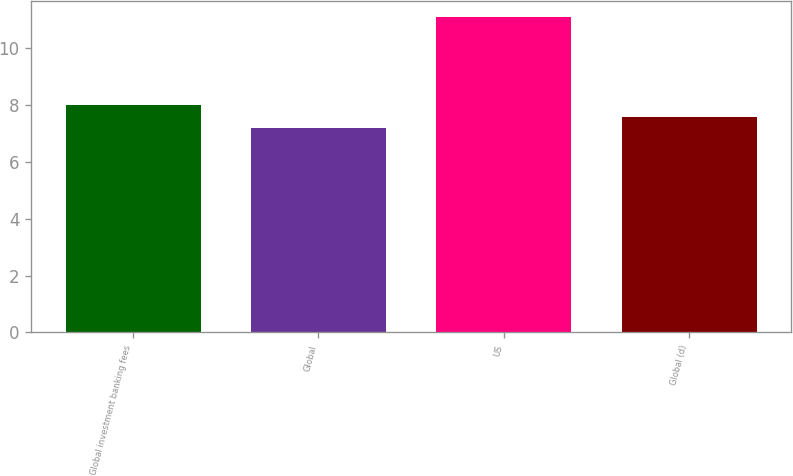Convert chart. <chart><loc_0><loc_0><loc_500><loc_500><bar_chart><fcel>Global investment banking fees<fcel>Global<fcel>US<fcel>Global (d)<nl><fcel>7.98<fcel>7.2<fcel>11.1<fcel>7.59<nl></chart> 